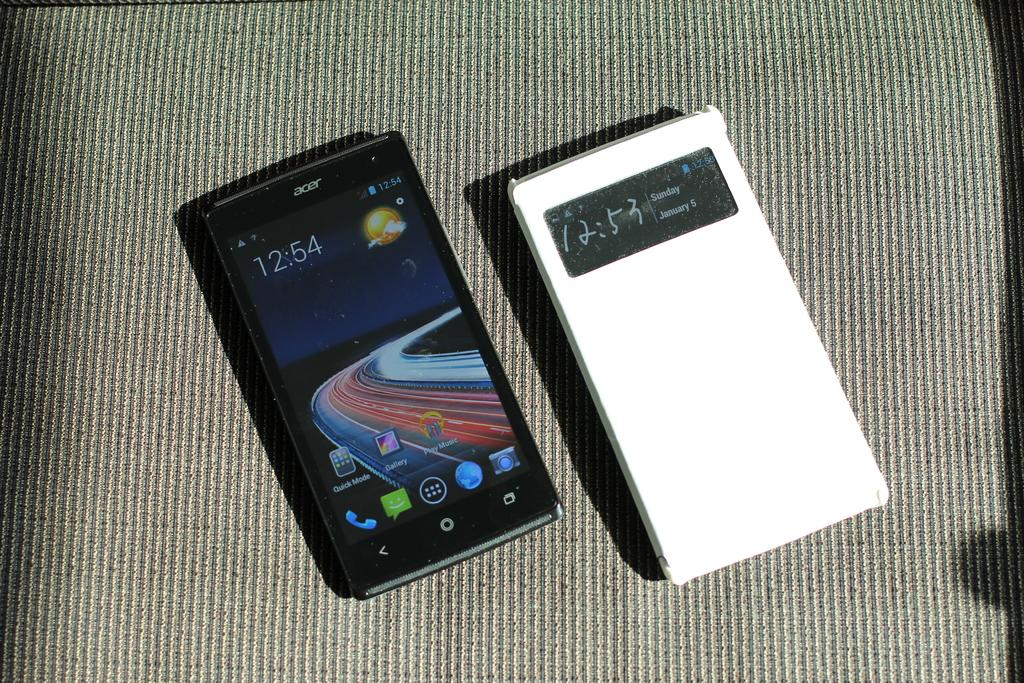<image>
Describe the image concisely. The black Acer smartphone has some cool graphics on it. 